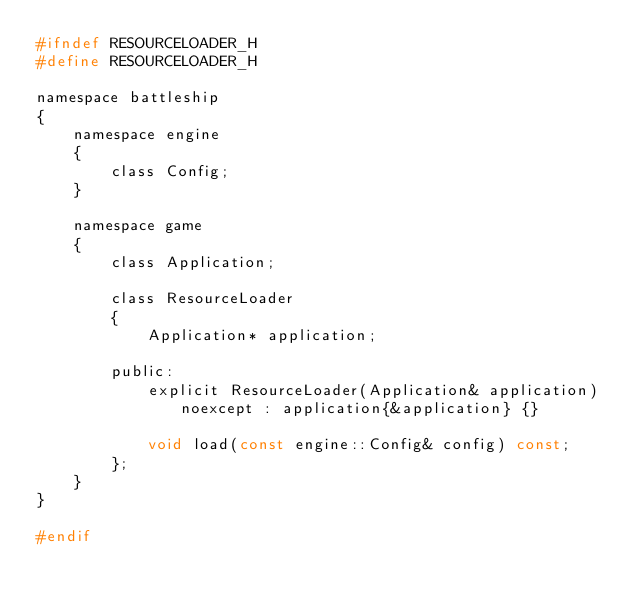Convert code to text. <code><loc_0><loc_0><loc_500><loc_500><_C_>#ifndef RESOURCELOADER_H
#define RESOURCELOADER_H

namespace battleship
{
    namespace engine
    {
        class Config;
    }

    namespace game
    {
        class Application;

        class ResourceLoader
        {
            Application* application;

        public:
            explicit ResourceLoader(Application& application) noexcept : application{&application} {}

            void load(const engine::Config& config) const;
        };
    }
}

#endif
</code> 